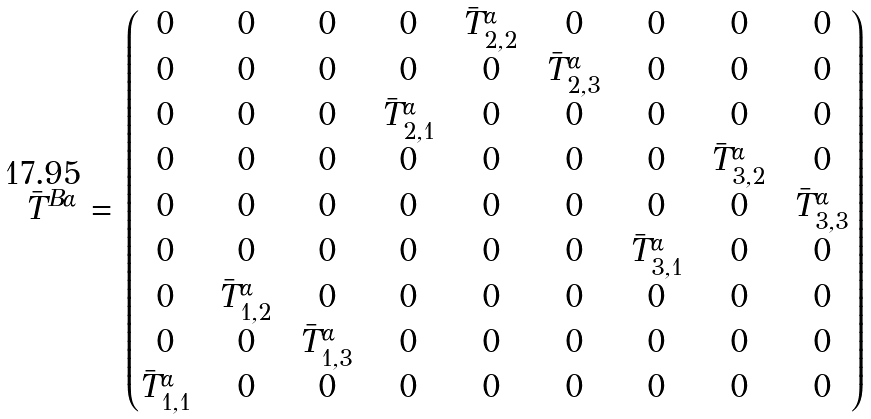<formula> <loc_0><loc_0><loc_500><loc_500>\bar { T } ^ { B \alpha } \, = \, \left ( \begin{matrix} 0 \, & \, 0 \, & \, 0 \, & \, 0 \, & \, \bar { T } ^ { \alpha } _ { 2 , 2 } \, & \, 0 \, & \, 0 \, & \, 0 \, & \, 0 \\ 0 \, & \, 0 \, & \, 0 \, & \, 0 \, & \, 0 \, & \, \bar { T } ^ { \alpha } _ { 2 , 3 } \, & \, 0 \, & \, 0 \, & \, 0 \\ 0 \, & \, 0 \, & \, 0 \, & \, \bar { T } ^ { \alpha } _ { 2 , 1 } \, & \, 0 \, & \, 0 \, & \, 0 \, & \, 0 \, & \, 0 \\ 0 \, & \, 0 \, & \, 0 \, & \, 0 \, & \, 0 \, & \, 0 \, & \, 0 \, & \, \bar { T } ^ { \alpha } _ { 3 , 2 } \, & \, 0 \\ 0 \, & \, 0 \, & \, 0 \, & \, 0 \, & \, 0 \, & \, 0 \, & \, 0 \, & \, 0 \, & \, \bar { T } ^ { \alpha } _ { 3 , 3 } \\ 0 \, & \, 0 \, & \, 0 \, & \, 0 \, & \, 0 \, & \, 0 \, & \, \bar { T } ^ { \alpha } _ { 3 , 1 } \, & \, 0 \, & \, 0 \\ 0 \, & \, \bar { T } ^ { \alpha } _ { 1 , 2 } \, & \, 0 \, & \, 0 \, & \, 0 \, & \, 0 \, & \, 0 \, & \, 0 \, & \, 0 \\ 0 \, & \, 0 \, & \, \bar { T } ^ { \alpha } _ { 1 , 3 } \, & \, 0 \, & \, 0 \, & \, 0 \, & \, 0 \, & \, 0 \, & \, 0 \\ \bar { T } ^ { \alpha } _ { 1 , 1 } \, & \, 0 \, & \, 0 \, & \, 0 \, & \, 0 \, & \, 0 \, & \, 0 \, & \, 0 \, & \, 0 \end{matrix} \right )</formula> 